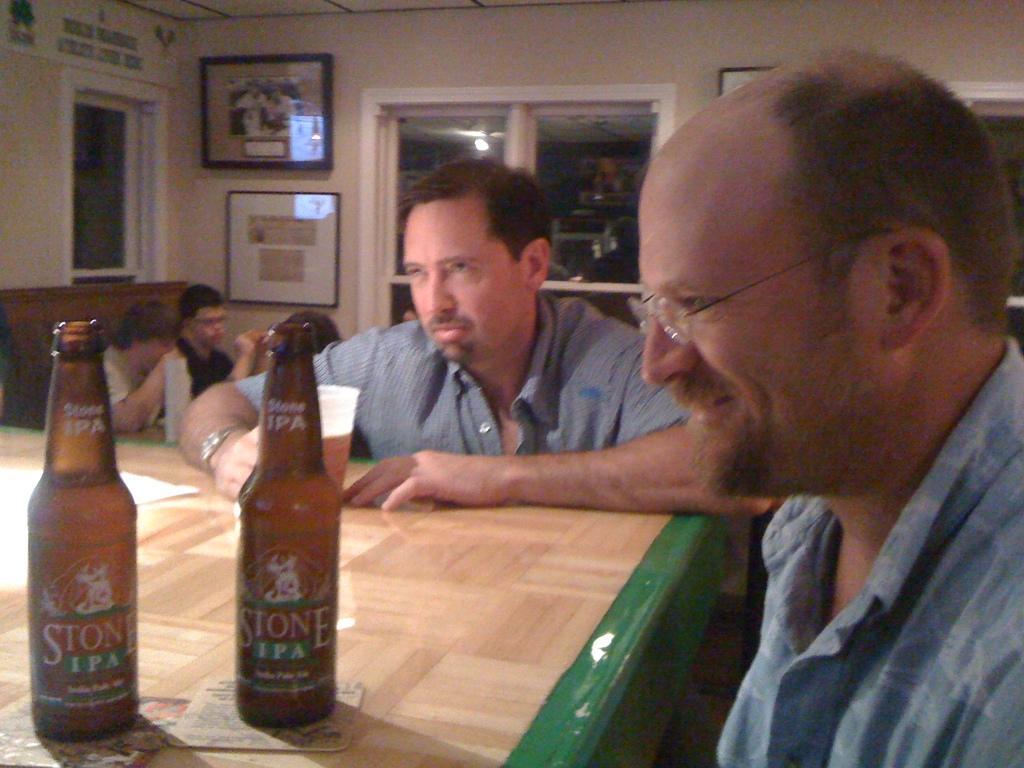Could you give a brief overview of what you see in this image? In this image there are two people those who are sitting around the table and there are cool drink bottles on the table, there are portraits at the right side of the image and there is a window at the center of the image. 